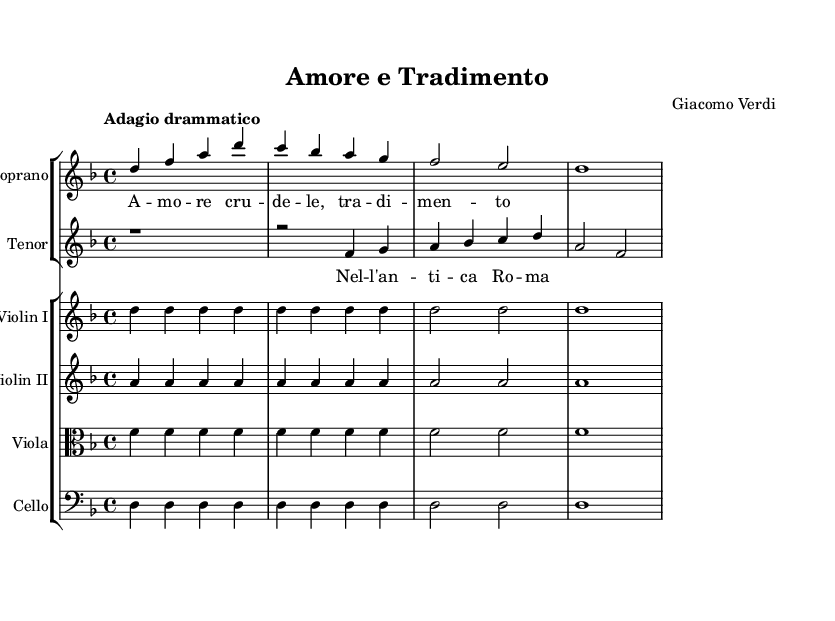What is the key signature of this music? The key signature is D minor, which is indicated by one flat (B♭). The key is recognizable by the presence of the flat sign at the beginning of the staff.
Answer: D minor What is the time signature of this piece? The time signature is 4/4, indicated by the numbers shown at the beginning of the staff. This means there are four beats per measure, and the quarter note gets one beat.
Answer: 4/4 What is the tempo marking for this music? The tempo marking is "Adagio drammatico," which suggests a slow and dramatic pace for the performance. This marking is typically located at the beginning of the music after the time signature.
Answer: Adagio drammatico How many measures are there in the soprano part? The soprano part has four measures, as can be counted visually from the start to the end of the part. Each bar line signifies the end of a measure.
Answer: Four What instrument is playing the lowest part in this score? The cello is the instrument that plays the lowest part, as indicated by its placement in the score and its bass clef notation, which is standard for this instrument.
Answer: Cello What lyrical theme do the soprano and tenor voices explore? The lyrical theme explored by the soprano and tenor voices revolves around love ("Amore") and betrayal ("Tradimento"), as indicated in the translated lyrics presented in the score.
Answer: Love and betrayal What is the name of the composer for this opera? The composer is Giacomo Verdi, whose name is listed in the header of the sheet music, identifying him as the creator of this work.
Answer: Giacomo Verdi 